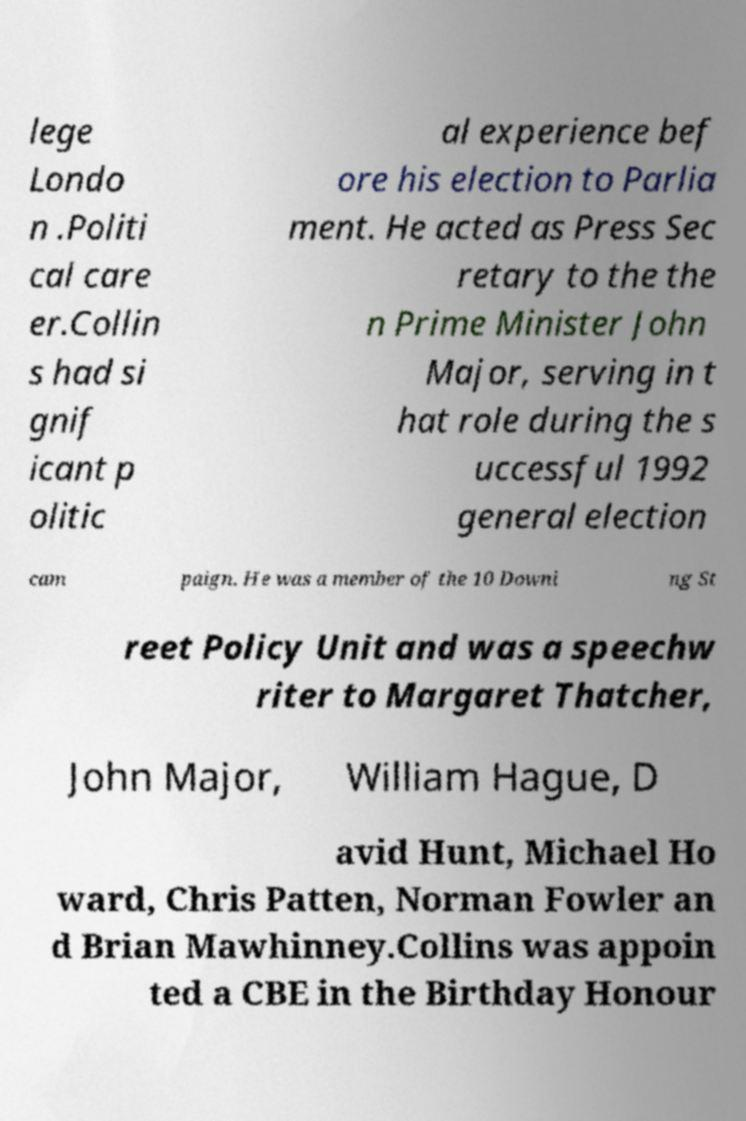Could you extract and type out the text from this image? lege Londo n .Politi cal care er.Collin s had si gnif icant p olitic al experience bef ore his election to Parlia ment. He acted as Press Sec retary to the the n Prime Minister John Major, serving in t hat role during the s uccessful 1992 general election cam paign. He was a member of the 10 Downi ng St reet Policy Unit and was a speechw riter to Margaret Thatcher, John Major, William Hague, D avid Hunt, Michael Ho ward, Chris Patten, Norman Fowler an d Brian Mawhinney.Collins was appoin ted a CBE in the Birthday Honour 